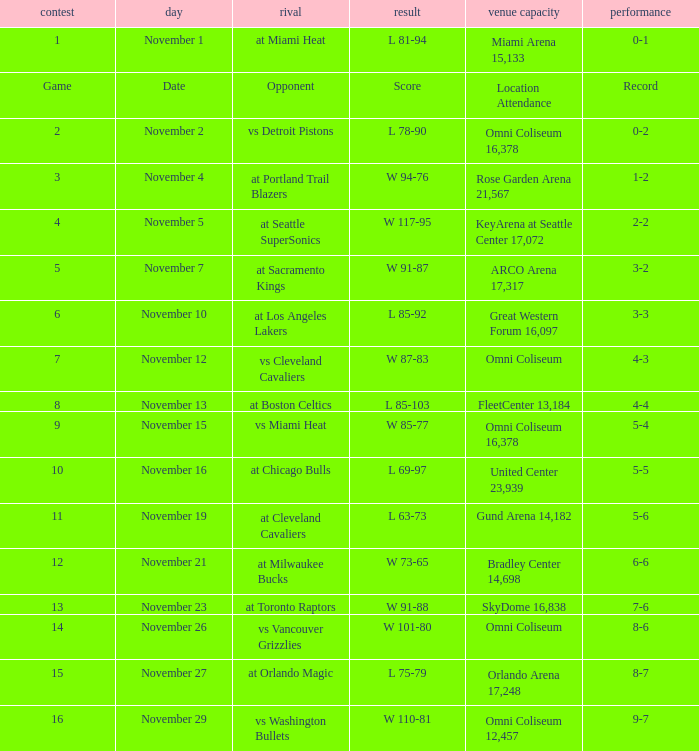On what date was game 3? November 4. 